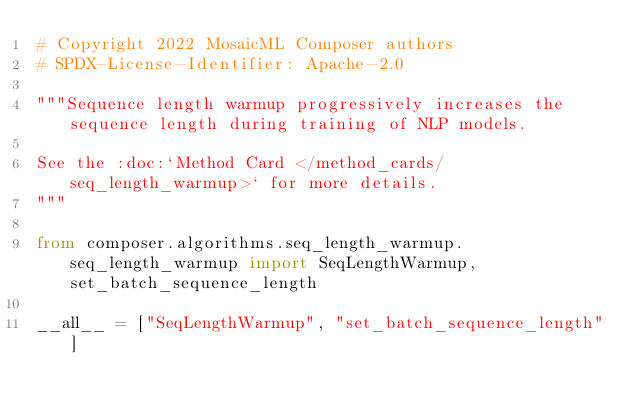Convert code to text. <code><loc_0><loc_0><loc_500><loc_500><_Python_># Copyright 2022 MosaicML Composer authors
# SPDX-License-Identifier: Apache-2.0

"""Sequence length warmup progressively increases the sequence length during training of NLP models.

See the :doc:`Method Card </method_cards/seq_length_warmup>` for more details.
"""

from composer.algorithms.seq_length_warmup.seq_length_warmup import SeqLengthWarmup, set_batch_sequence_length

__all__ = ["SeqLengthWarmup", "set_batch_sequence_length"]
</code> 